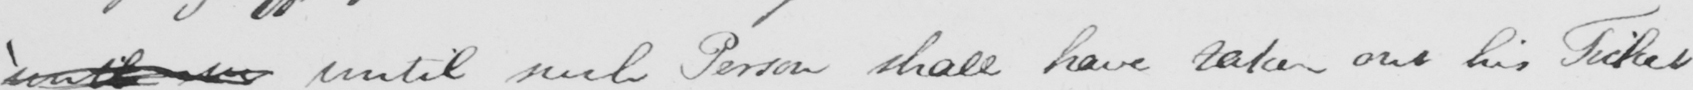Transcribe the text shown in this historical manuscript line. ' until in until such Person shall have taken out his Ticket 